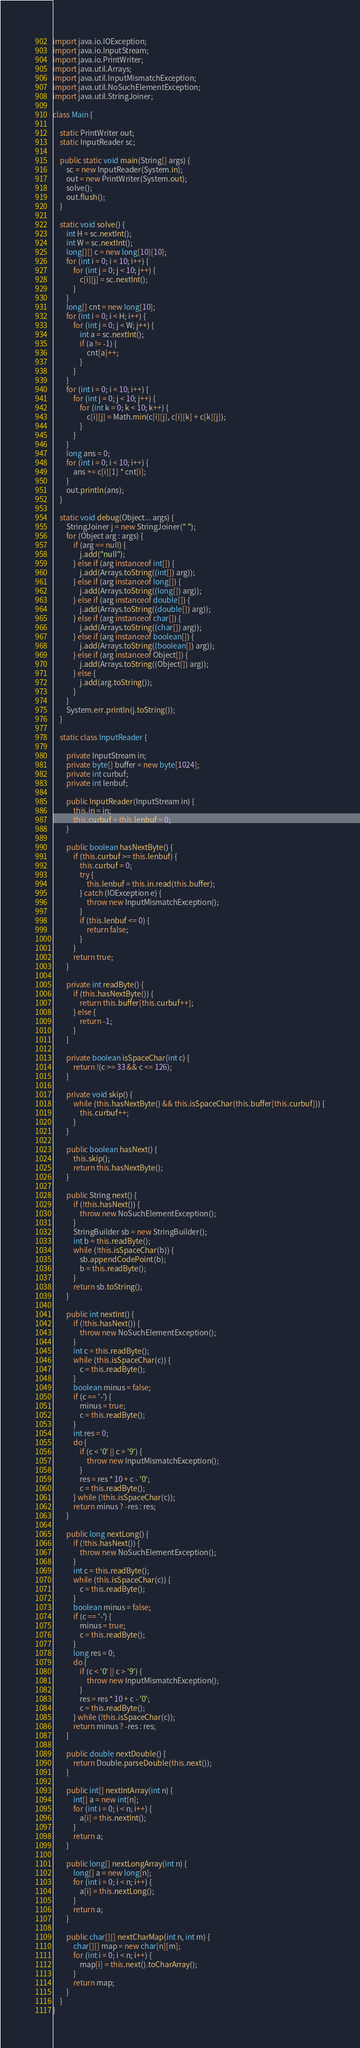<code> <loc_0><loc_0><loc_500><loc_500><_Java_>import java.io.IOException;
import java.io.InputStream;
import java.io.PrintWriter;
import java.util.Arrays;
import java.util.InputMismatchException;
import java.util.NoSuchElementException;
import java.util.StringJoiner;

class Main {

    static PrintWriter out;
    static InputReader sc;

    public static void main(String[] args) {
        sc = new InputReader(System.in);
        out = new PrintWriter(System.out);
        solve();
        out.flush();
    }

    static void solve() {
        int H = sc.nextInt();
        int W = sc.nextInt();
        long[][] c = new long[10][10];
        for (int i = 0; i < 10; i++) {
            for (int j = 0; j < 10; j++) {
                c[i][j] = sc.nextInt();
            }
        }
        long[] cnt = new long[10];
        for (int i = 0; i < H; i++) {
            for (int j = 0; j < W; j++) {
                int a = sc.nextInt();
                if (a != -1) {
                    cnt[a]++;
                }
            }
        }
        for (int i = 0; i < 10; i++) {
            for (int j = 0; j < 10; j++) {
                for (int k = 0; k < 10; k++) {
                    c[i][j] = Math.min(c[i][j], c[i][k] + c[k][j]);
                }
            }
        }
        long ans = 0;
        for (int i = 0; i < 10; i++) {
            ans += c[i][1] * cnt[i];
        }
        out.println(ans);
    }

    static void debug(Object... args) {
        StringJoiner j = new StringJoiner(" ");
        for (Object arg : args) {
            if (arg == null) {
                j.add("null");
            } else if (arg instanceof int[]) {
                j.add(Arrays.toString((int[]) arg));
            } else if (arg instanceof long[]) {
                j.add(Arrays.toString((long[]) arg));
            } else if (arg instanceof double[]) {
                j.add(Arrays.toString((double[]) arg));
            } else if (arg instanceof char[]) {
                j.add(Arrays.toString((char[]) arg));
            } else if (arg instanceof boolean[]) {
                j.add(Arrays.toString((boolean[]) arg));
            } else if (arg instanceof Object[]) {
                j.add(Arrays.toString((Object[]) arg));
            } else {
                j.add(arg.toString());
            }
        }
        System.err.println(j.toString());
    }

    static class InputReader {

        private InputStream in;
        private byte[] buffer = new byte[1024];
        private int curbuf;
        private int lenbuf;

        public InputReader(InputStream in) {
            this.in = in;
            this.curbuf = this.lenbuf = 0;
        }

        public boolean hasNextByte() {
            if (this.curbuf >= this.lenbuf) {
                this.curbuf = 0;
                try {
                    this.lenbuf = this.in.read(this.buffer);
                } catch (IOException e) {
                    throw new InputMismatchException();
                }
                if (this.lenbuf <= 0) {
                    return false;
                }
            }
            return true;
        }

        private int readByte() {
            if (this.hasNextByte()) {
                return this.buffer[this.curbuf++];
            } else {
                return -1;
            }
        }

        private boolean isSpaceChar(int c) {
            return !(c >= 33 && c <= 126);
        }

        private void skip() {
            while (this.hasNextByte() && this.isSpaceChar(this.buffer[this.curbuf])) {
                this.curbuf++;
            }
        }

        public boolean hasNext() {
            this.skip();
            return this.hasNextByte();
        }

        public String next() {
            if (!this.hasNext()) {
                throw new NoSuchElementException();
            }
            StringBuilder sb = new StringBuilder();
            int b = this.readByte();
            while (!this.isSpaceChar(b)) {
                sb.appendCodePoint(b);
                b = this.readByte();
            }
            return sb.toString();
        }

        public int nextInt() {
            if (!this.hasNext()) {
                throw new NoSuchElementException();
            }
            int c = this.readByte();
            while (this.isSpaceChar(c)) {
                c = this.readByte();
            }
            boolean minus = false;
            if (c == '-') {
                minus = true;
                c = this.readByte();
            }
            int res = 0;
            do {
                if (c < '0' || c > '9') {
                    throw new InputMismatchException();
                }
                res = res * 10 + c - '0';
                c = this.readByte();
            } while (!this.isSpaceChar(c));
            return minus ? -res : res;
        }

        public long nextLong() {
            if (!this.hasNext()) {
                throw new NoSuchElementException();
            }
            int c = this.readByte();
            while (this.isSpaceChar(c)) {
                c = this.readByte();
            }
            boolean minus = false;
            if (c == '-') {
                minus = true;
                c = this.readByte();
            }
            long res = 0;
            do {
                if (c < '0' || c > '9') {
                    throw new InputMismatchException();
                }
                res = res * 10 + c - '0';
                c = this.readByte();
            } while (!this.isSpaceChar(c));
            return minus ? -res : res;
        }

        public double nextDouble() {
            return Double.parseDouble(this.next());
        }

        public int[] nextIntArray(int n) {
            int[] a = new int[n];
            for (int i = 0; i < n; i++) {
                a[i] = this.nextInt();
            }
            return a;
        }

        public long[] nextLongArray(int n) {
            long[] a = new long[n];
            for (int i = 0; i < n; i++) {
                a[i] = this.nextLong();
            }
            return a;
        }

        public char[][] nextCharMap(int n, int m) {
            char[][] map = new char[n][m];
            for (int i = 0; i < n; i++) {
                map[i] = this.next().toCharArray();
            }
            return map;
        }
    }
}</code> 